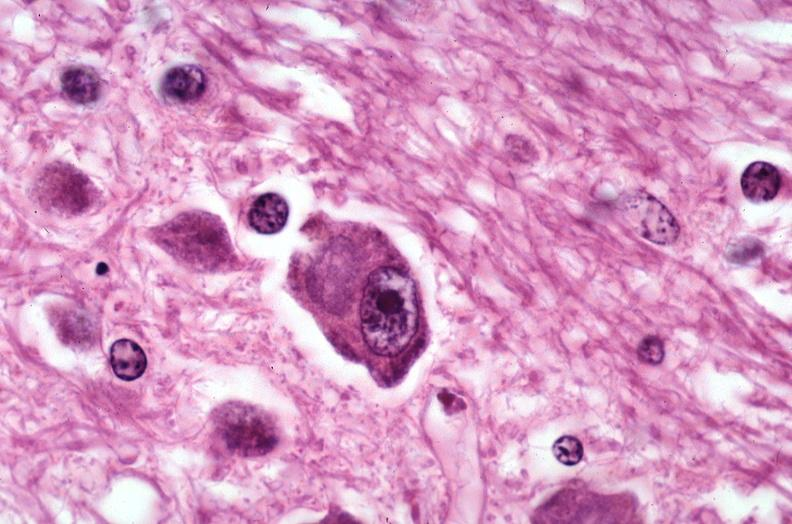s nervous present?
Answer the question using a single word or phrase. Yes 